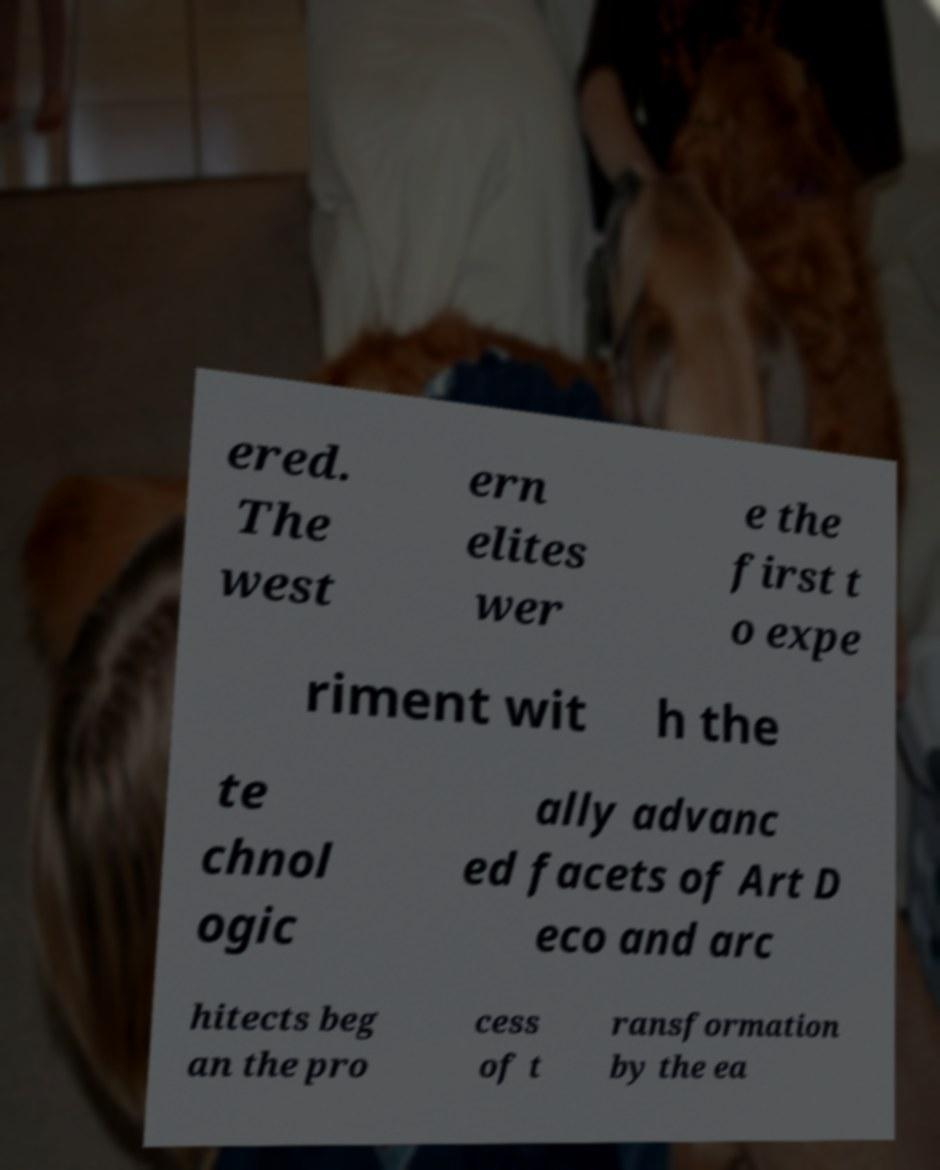Could you assist in decoding the text presented in this image and type it out clearly? ered. The west ern elites wer e the first t o expe riment wit h the te chnol ogic ally advanc ed facets of Art D eco and arc hitects beg an the pro cess of t ransformation by the ea 